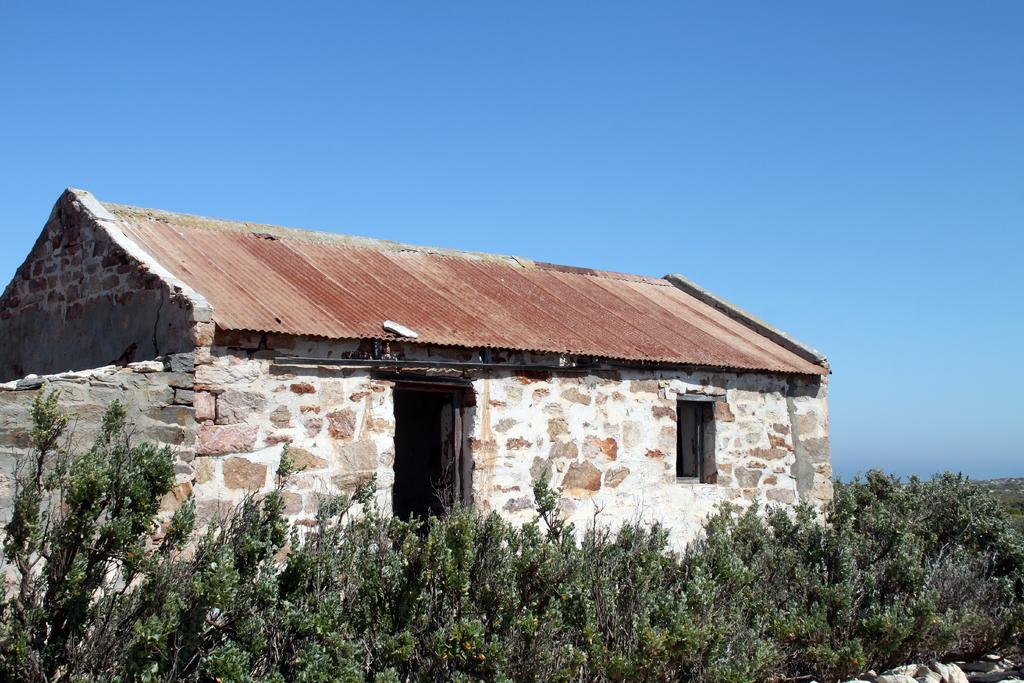What type of structure is visible in the image? There is a roof house in the image. What can be seen at the bottom of the image? There are plants at the bottom of the image. What is visible at the top of the image? The sky is visible at the top of the image. How many oranges are hanging from the roof house in the image? There are no oranges present in the image. 